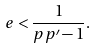Convert formula to latex. <formula><loc_0><loc_0><loc_500><loc_500>\ e < \frac { 1 } { p p ^ { \prime } - 1 } .</formula> 